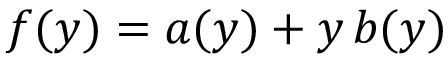<formula> <loc_0><loc_0><loc_500><loc_500>f ( y ) = a ( y ) + y \, b ( y )</formula> 